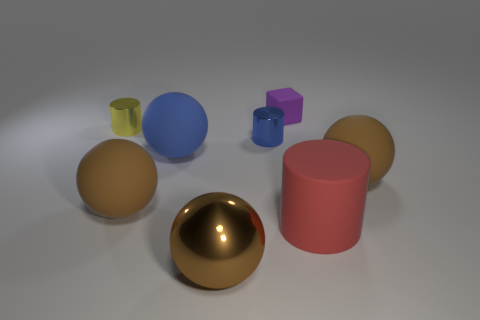Subtract all gray cylinders. How many brown spheres are left? 3 Add 1 blue things. How many objects exist? 9 Subtract all cylinders. How many objects are left? 5 Subtract 0 green cylinders. How many objects are left? 8 Subtract all balls. Subtract all brown metallic things. How many objects are left? 3 Add 1 big brown things. How many big brown things are left? 4 Add 2 purple cubes. How many purple cubes exist? 3 